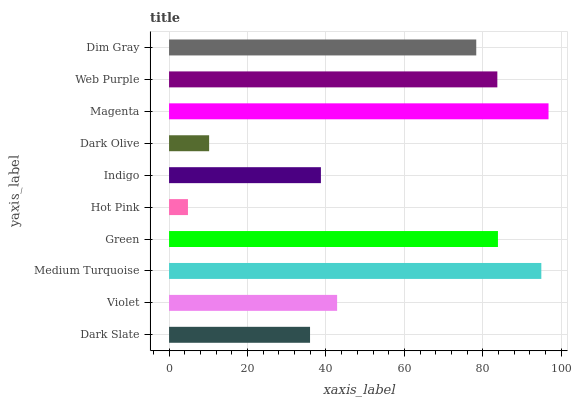Is Hot Pink the minimum?
Answer yes or no. Yes. Is Magenta the maximum?
Answer yes or no. Yes. Is Violet the minimum?
Answer yes or no. No. Is Violet the maximum?
Answer yes or no. No. Is Violet greater than Dark Slate?
Answer yes or no. Yes. Is Dark Slate less than Violet?
Answer yes or no. Yes. Is Dark Slate greater than Violet?
Answer yes or no. No. Is Violet less than Dark Slate?
Answer yes or no. No. Is Dim Gray the high median?
Answer yes or no. Yes. Is Violet the low median?
Answer yes or no. Yes. Is Hot Pink the high median?
Answer yes or no. No. Is Dark Slate the low median?
Answer yes or no. No. 